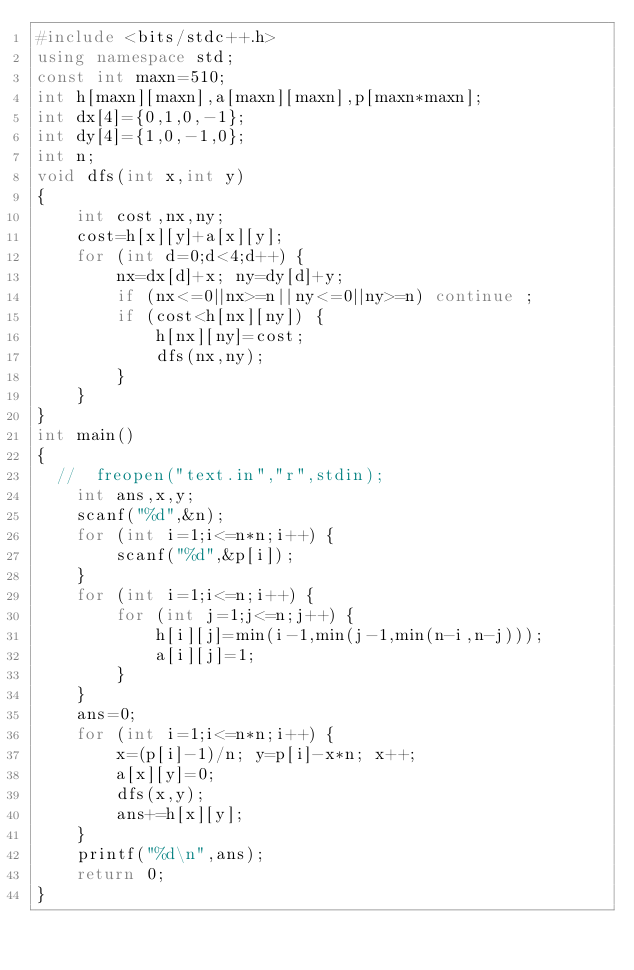<code> <loc_0><loc_0><loc_500><loc_500><_C++_>#include <bits/stdc++.h>
using namespace std;
const int maxn=510;
int h[maxn][maxn],a[maxn][maxn],p[maxn*maxn];
int dx[4]={0,1,0,-1};
int dy[4]={1,0,-1,0};
int n;
void dfs(int x,int y)
{
    int cost,nx,ny;
    cost=h[x][y]+a[x][y];
    for (int d=0;d<4;d++) {
        nx=dx[d]+x; ny=dy[d]+y;
        if (nx<=0||nx>=n||ny<=0||ny>=n) continue ;
        if (cost<h[nx][ny]) {
            h[nx][ny]=cost;
            dfs(nx,ny);
        }
    }
}
int main()
{
  //  freopen("text.in","r",stdin);
    int ans,x,y;
    scanf("%d",&n);
    for (int i=1;i<=n*n;i++) {
        scanf("%d",&p[i]);
    }
    for (int i=1;i<=n;i++) {
        for (int j=1;j<=n;j++) {
            h[i][j]=min(i-1,min(j-1,min(n-i,n-j)));
            a[i][j]=1;
        }
    }
    ans=0;
    for (int i=1;i<=n*n;i++) {
        x=(p[i]-1)/n; y=p[i]-x*n; x++;
        a[x][y]=0;
        dfs(x,y);
        ans+=h[x][y];
    }
    printf("%d\n",ans);
    return 0;
}
</code> 